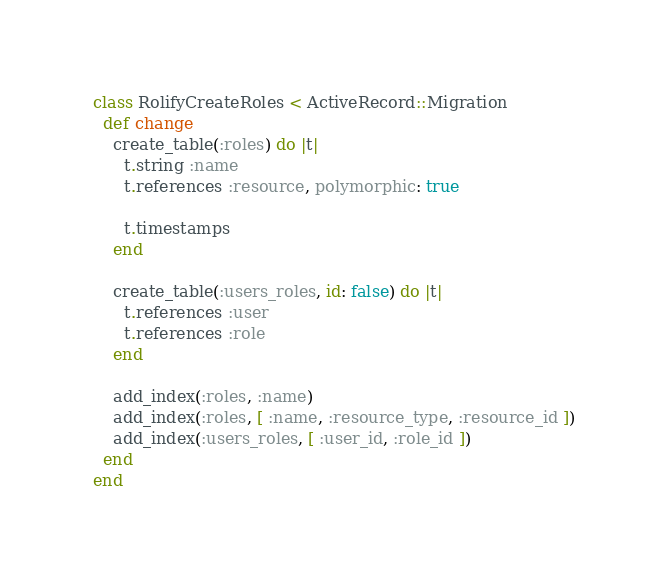<code> <loc_0><loc_0><loc_500><loc_500><_Ruby_>class RolifyCreateRoles < ActiveRecord::Migration
  def change
    create_table(:roles) do |t|
      t.string :name
      t.references :resource, polymorphic: true

      t.timestamps
    end

    create_table(:users_roles, id: false) do |t|
      t.references :user
      t.references :role
    end

    add_index(:roles, :name)
    add_index(:roles, [ :name, :resource_type, :resource_id ])
    add_index(:users_roles, [ :user_id, :role_id ])
  end
end</code> 